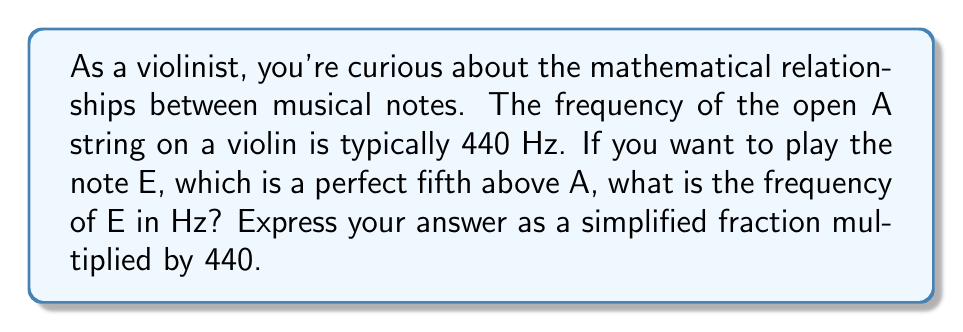Help me with this question. To solve this problem, we need to understand the relationship between musical intervals and frequency ratios:

1) In Western music theory, a perfect fifth interval has a frequency ratio of 3:2.

2) This means that if we start with a frequency $f$, the frequency of the note a perfect fifth above it will be $\frac{3}{2}f$.

3) In this case, we start with A at 440 Hz, so we can set up the equation:

   $f_E = \frac{3}{2} \cdot 440$ Hz

4) To express this as a simplified fraction multiplied by 440:

   $f_E = \frac{3}{2} \cdot 440 = \frac{3}{2} \cdot 440 \cdot \frac{1}{1} = 440 \cdot \frac{3}{2}$ Hz

Thus, the frequency of E is $440 \cdot \frac{3}{2}$ Hz.
Answer: $440 \cdot \frac{3}{2}$ Hz 